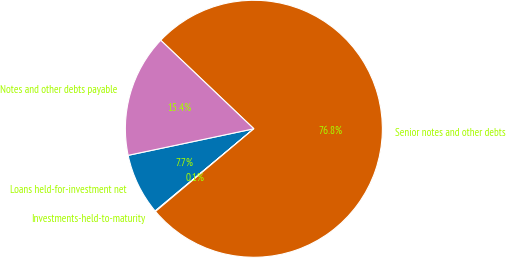Convert chart. <chart><loc_0><loc_0><loc_500><loc_500><pie_chart><fcel>Loans held-for-investment net<fcel>Investments-held-to-maturity<fcel>Senior notes and other debts<fcel>Notes and other debts payable<nl><fcel>7.74%<fcel>0.07%<fcel>76.78%<fcel>15.41%<nl></chart> 